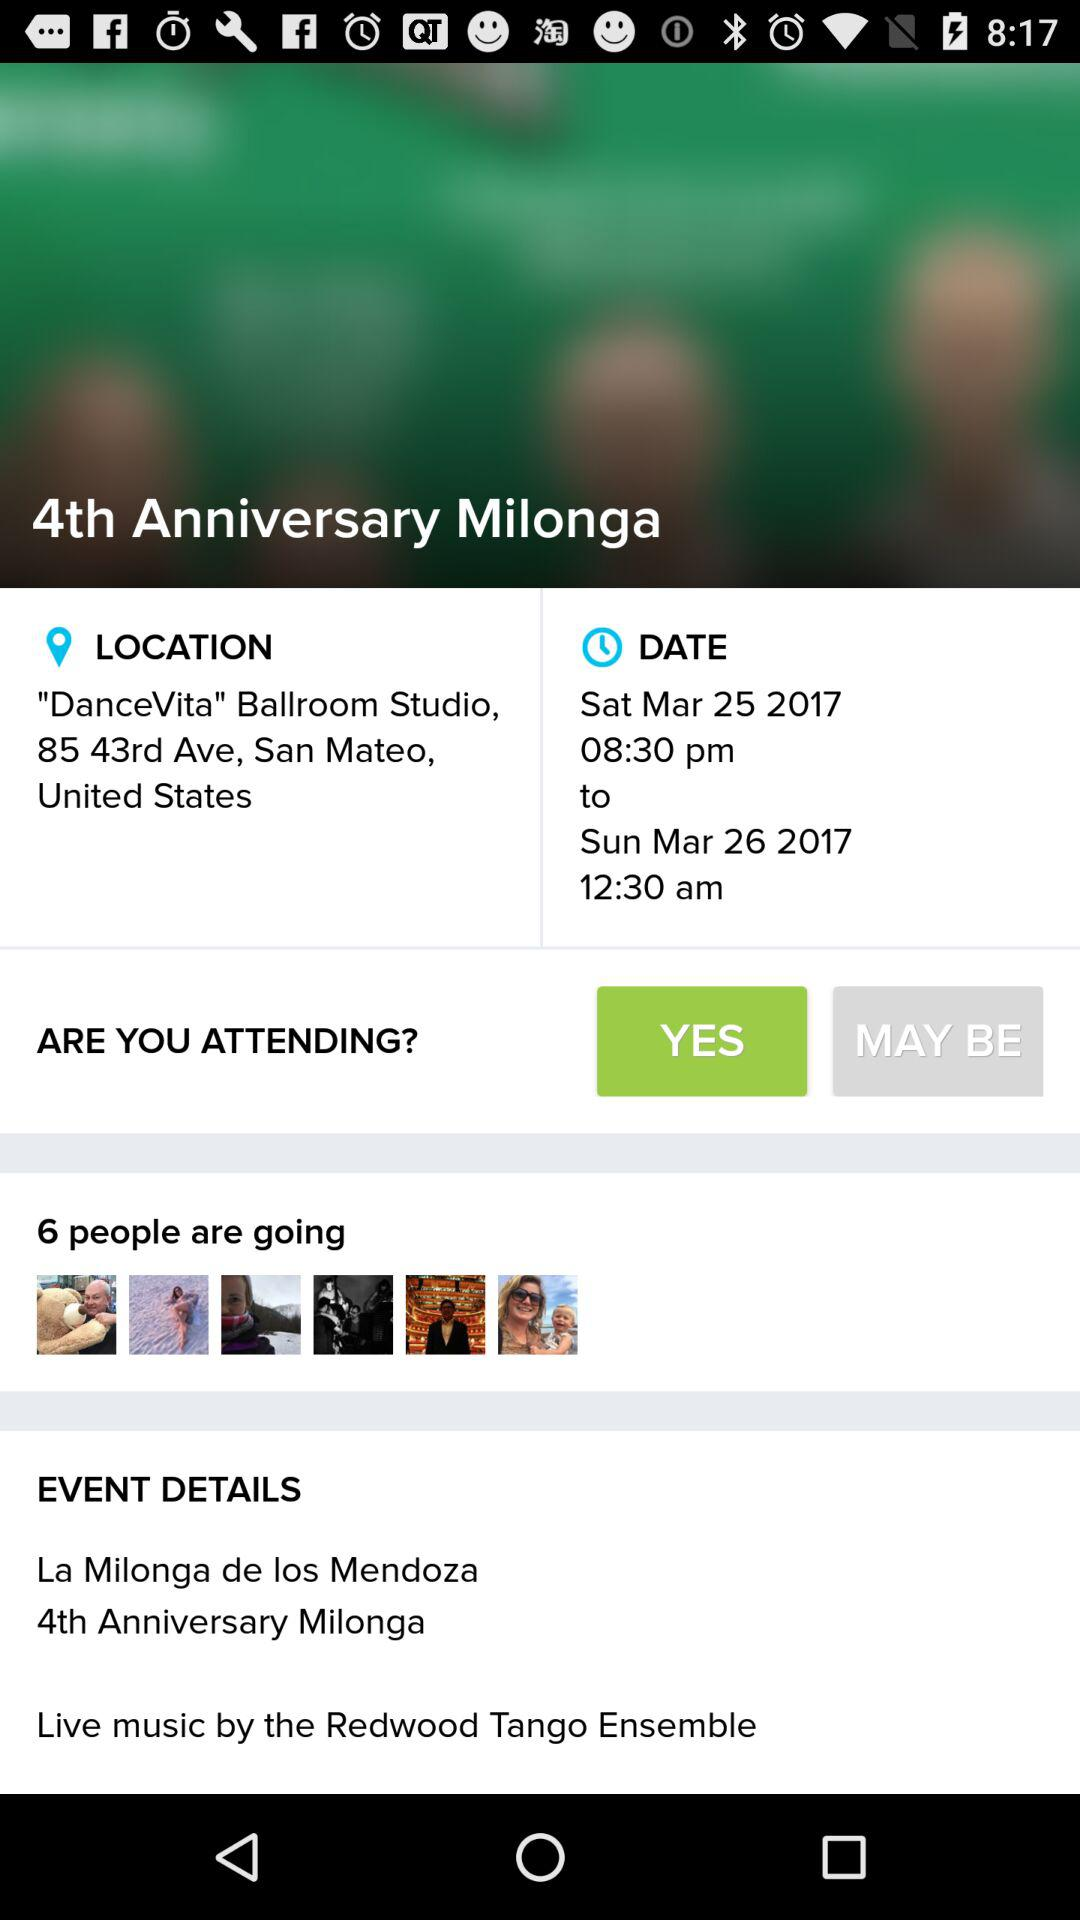What is the venue? The venue is the clubhouse at Rancho Solano. 